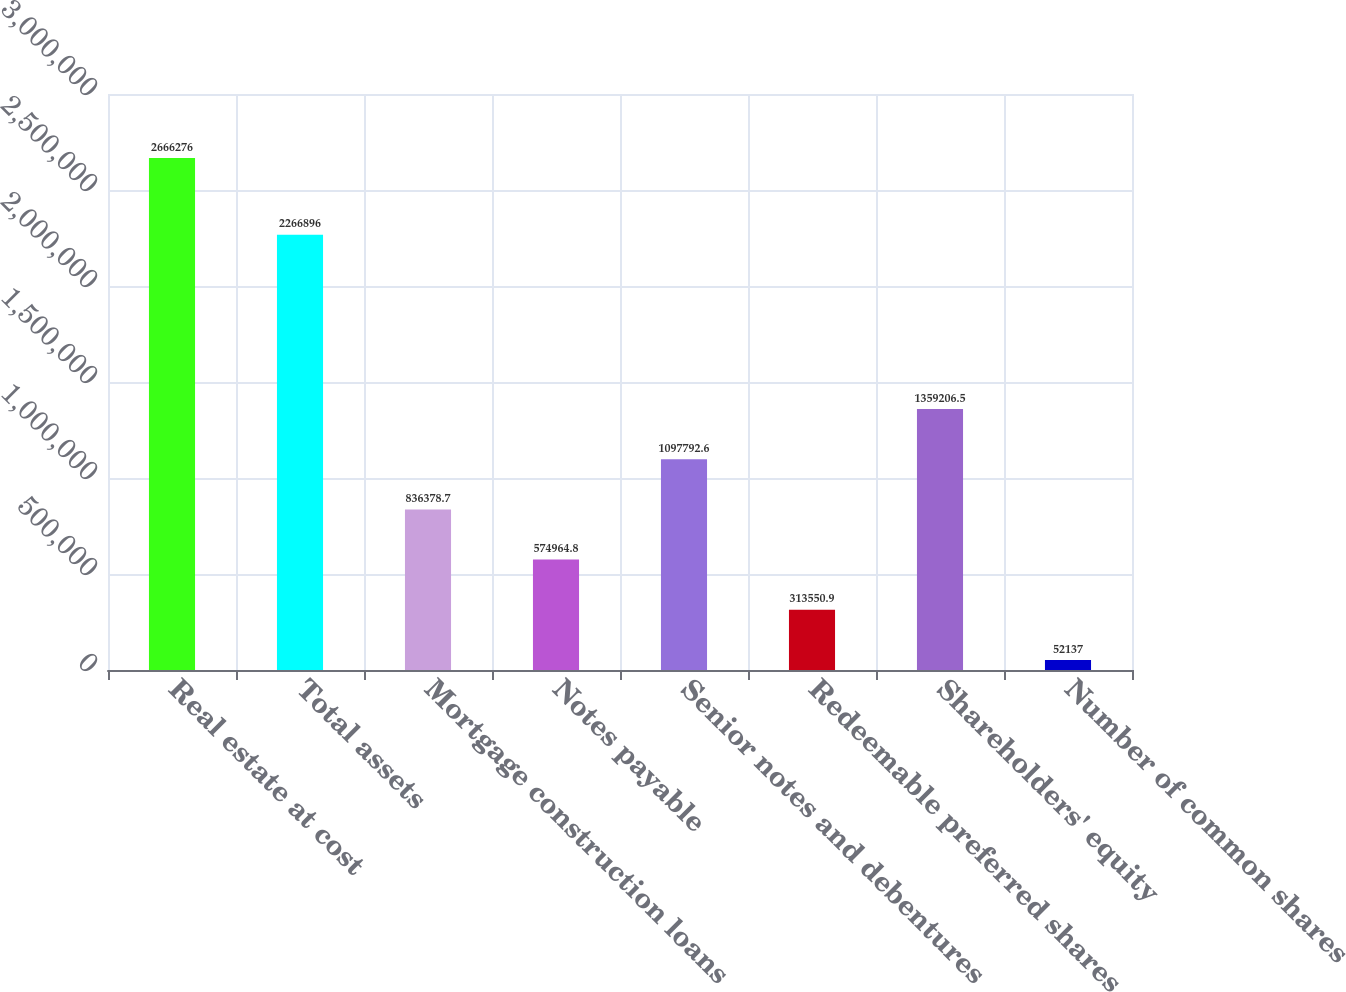<chart> <loc_0><loc_0><loc_500><loc_500><bar_chart><fcel>Real estate at cost<fcel>Total assets<fcel>Mortgage construction loans<fcel>Notes payable<fcel>Senior notes and debentures<fcel>Redeemable preferred shares<fcel>Shareholders' equity<fcel>Number of common shares<nl><fcel>2.66628e+06<fcel>2.2669e+06<fcel>836379<fcel>574965<fcel>1.09779e+06<fcel>313551<fcel>1.35921e+06<fcel>52137<nl></chart> 